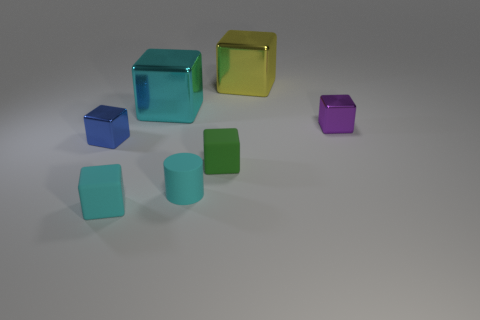What is the material of the tiny cyan cylinder in front of the big metallic thing that is on the left side of the yellow object? The tiny cyan object appears to be a cylinder made of a matte material that could resemble plastic or a similarly opaque material, not rubber as previously stated. Due to the image's quality and the absence of context that would provide definitive clues about the material, we can't say with certainty what it is. However, judging by the light reflection and the context of the other objects, it seems less likely to be rubber. 